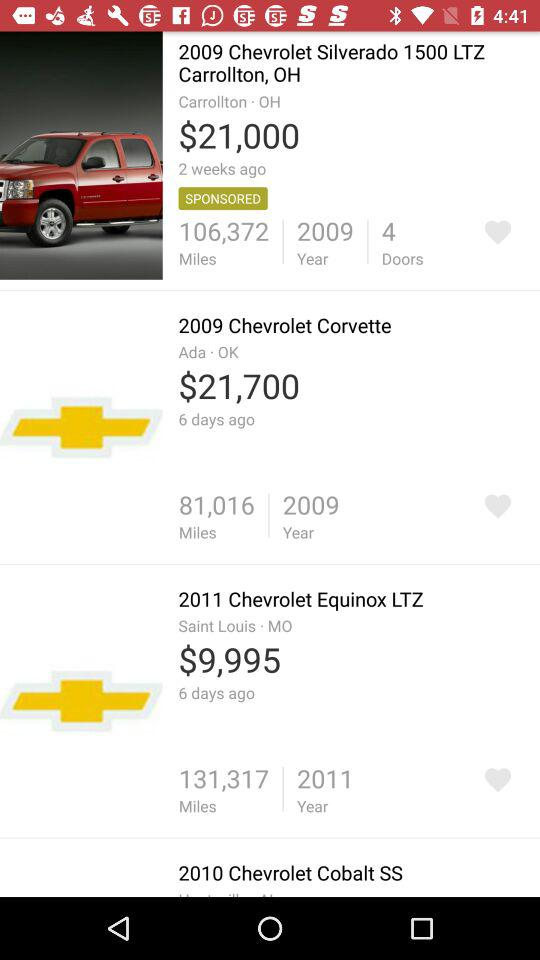Which item has the most miles on it?
Answer the question using a single word or phrase. 2011 Chevrolet Equinox LTZ 